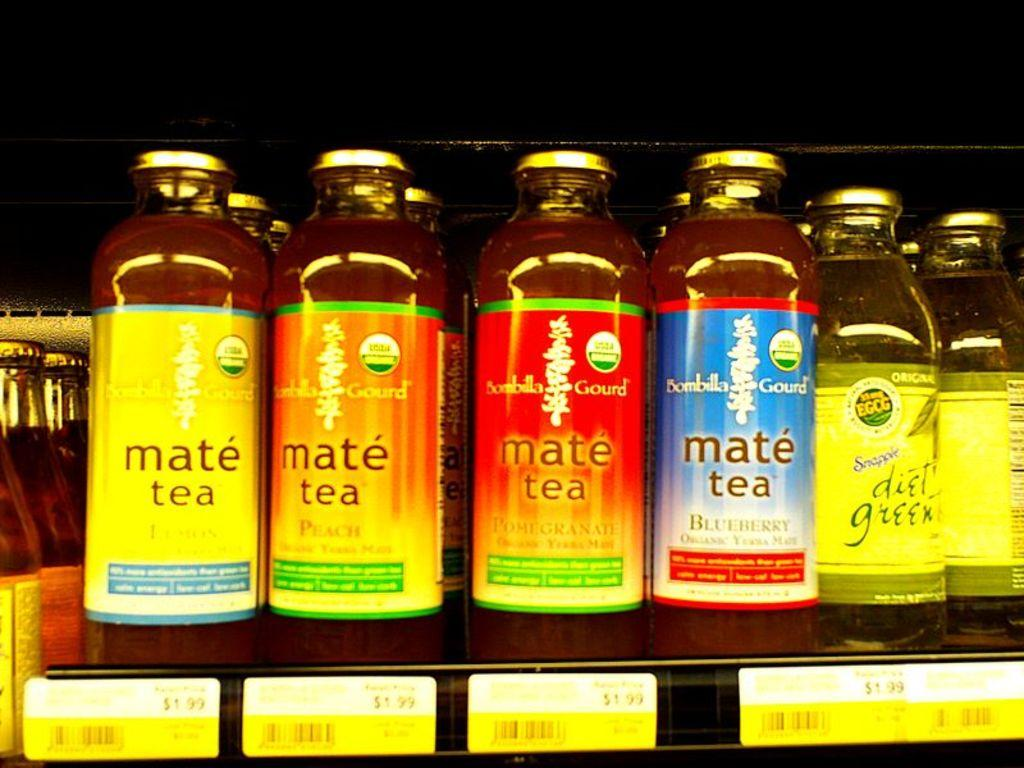<image>
Give a short and clear explanation of the subsequent image. a shelf of mate tea in different flavors such as blueberry and peach 